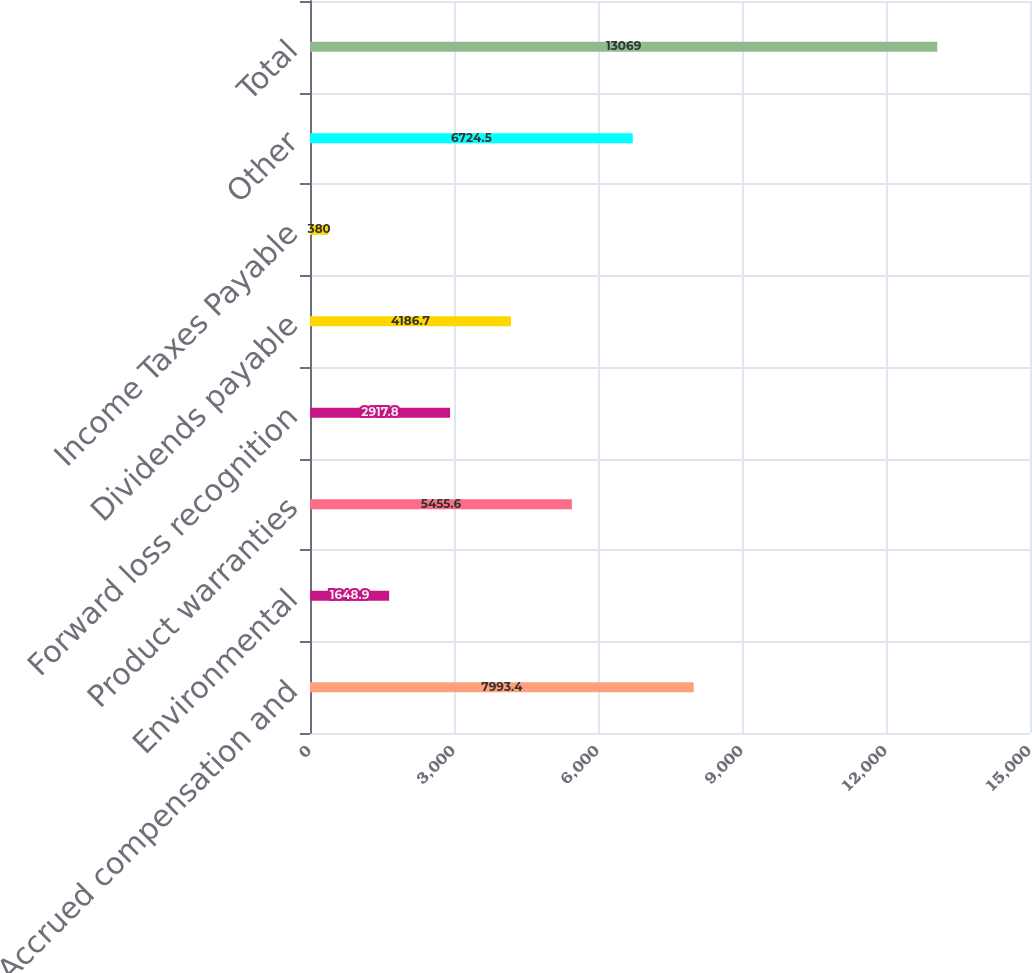Convert chart. <chart><loc_0><loc_0><loc_500><loc_500><bar_chart><fcel>Accrued compensation and<fcel>Environmental<fcel>Product warranties<fcel>Forward loss recognition<fcel>Dividends payable<fcel>Income Taxes Payable<fcel>Other<fcel>Total<nl><fcel>7993.4<fcel>1648.9<fcel>5455.6<fcel>2917.8<fcel>4186.7<fcel>380<fcel>6724.5<fcel>13069<nl></chart> 